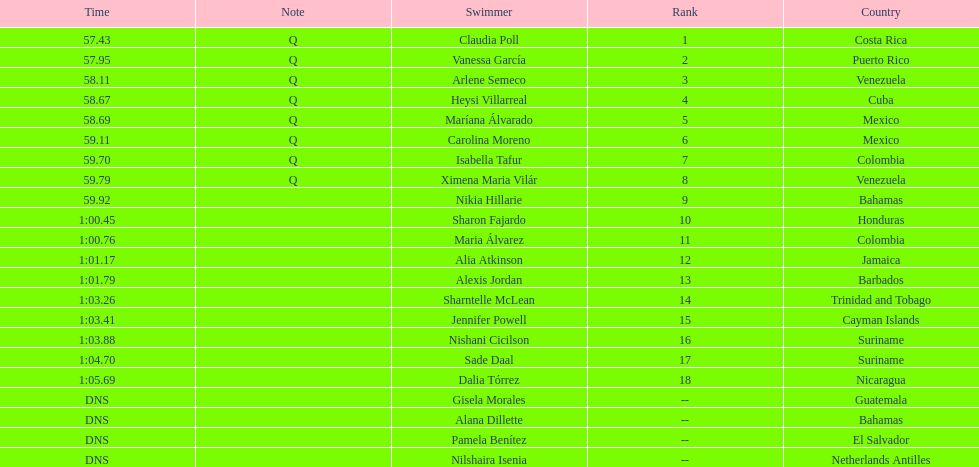How many competitors from venezuela qualified for the final? 2. 